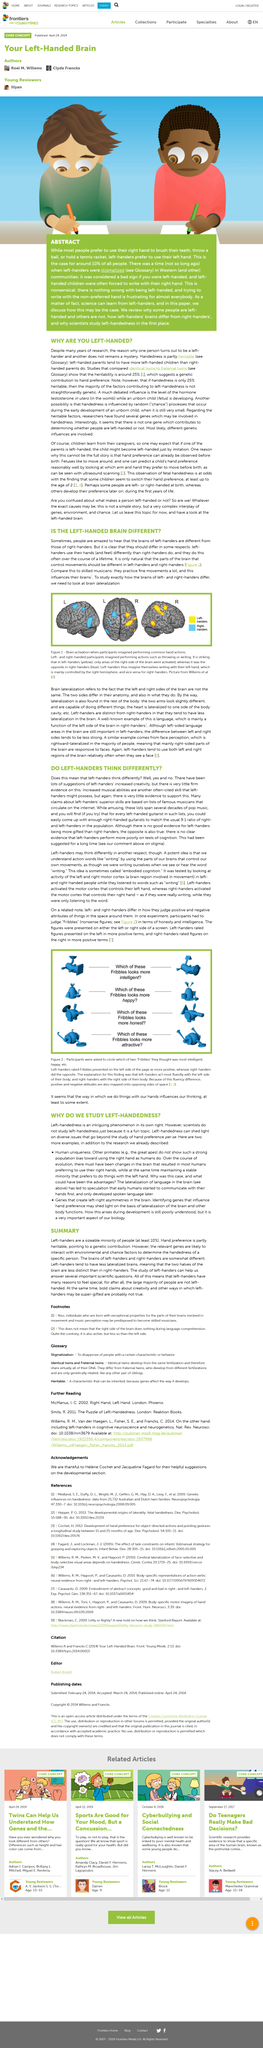Give some essential details in this illustration. Approximately 10% of the population is left-handed. The claim that left-handers are super-gifted in creativity and other ways is probably not true. Musicians' brains can be influenced by the frequent practice of fine movements, as demonstrated by their ability to perform complex musical pieces with precision and accuracy. Yes, the brains of left-handers and right-handers are somewhat different from each other. Researchers study the differences between right and left-handed individuals by examining brain lateralization, which is the process of determining which side of the brain is dominant for certain functions. This is done by analyzing the structure and function of the brain, as well as observing behavior and cognitive abilities. 